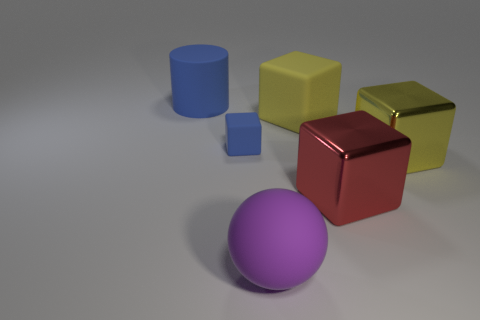Are there any other things that are the same size as the blue matte cube?
Offer a terse response. No. Does the ball have the same size as the red cube?
Offer a terse response. Yes. The blue matte cylinder has what size?
Your response must be concise. Large. What shape is the big thing that is the same color as the tiny object?
Provide a short and direct response. Cylinder. Are there more small blue shiny things than tiny blue objects?
Ensure brevity in your answer.  No. What color is the matte cube that is left of the large block behind the blue rubber object to the right of the cylinder?
Provide a short and direct response. Blue. There is a large object behind the big yellow matte object; is its shape the same as the big purple thing?
Offer a terse response. No. There is a shiny thing that is the same size as the red metal block; what is its color?
Your answer should be very brief. Yellow. How many blue rubber cylinders are there?
Ensure brevity in your answer.  1. Do the yellow cube behind the big yellow metallic cube and the purple object have the same material?
Offer a very short reply. Yes. 